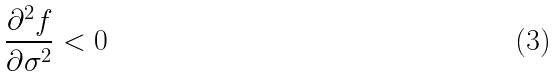Convert formula to latex. <formula><loc_0><loc_0><loc_500><loc_500>\frac { \partial ^ { 2 } f } { \partial \sigma ^ { 2 } } < 0</formula> 